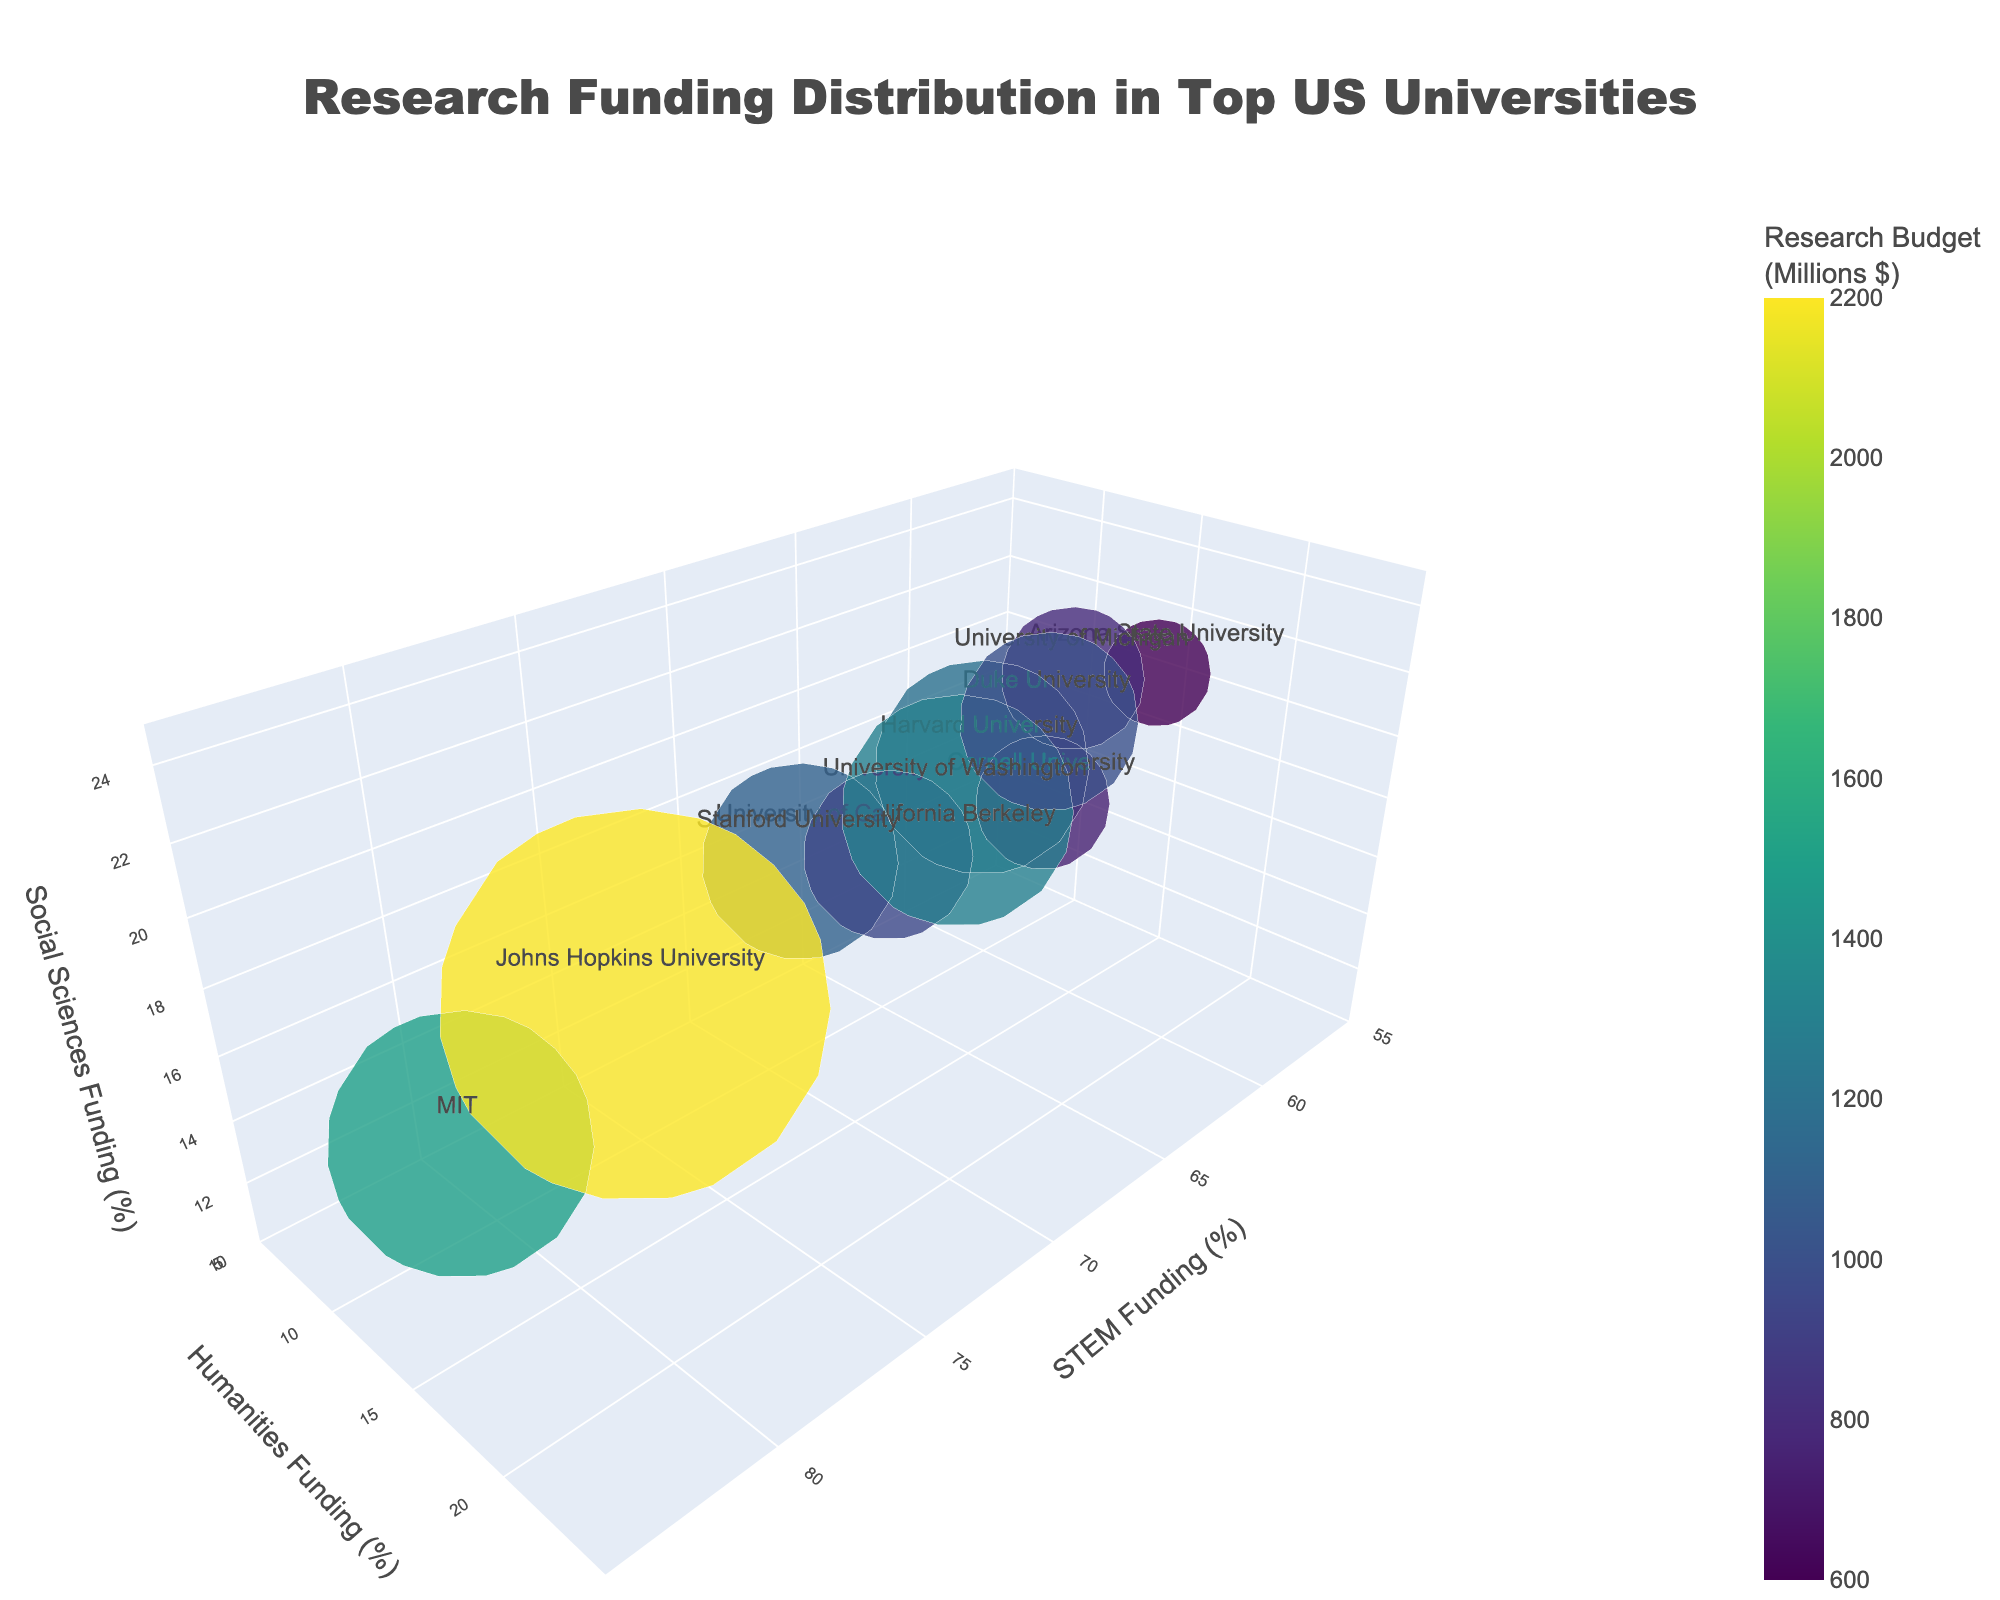How many universities are represented in the chart? Count the number of unique institutions listed in the hovertext information.
Answer: 10 What is the title of the chart? Look at the title at the top center of the chart.
Answer: "Research Funding Distribution in Top US Universities" Which institution has the highest total research budget? Look at the color scale and hover over the largest bubble.
Answer: Johns Hopkins University Which institution allocates the largest percentage of its research funding to Humanities? Hover over each bubble and examine the percentages.
Answer: Arizona State University What are the axes titles in the chart? Look at the labels on the three axes in the 3D space.
Answer: STEM Funding (%), Humanities Funding (%), Social Sciences Funding (%) How is the size of the bubbles determined? Examine the dataset; it mentions that the size is proportional to the total research budget divided by 10.
Answer: Total Research Budget (scaled) Which two institutions have the most similar distribution of research funding across STEM, Humanities, and Social Sciences? Compare the percentages in the hovertexts.
Answer: University of Michigan and Duke University Describe the research funding distribution for Stanford University. Hover over Stanford University and note the percentages for each category.
Answer: STEM: 70%, Humanities: 12%, Social Sciences: 18% What is the total research budget of Harvard University? Hover over Harvard University's bubble and note the budget mentioned.
Answer: $1200M Which institution has the smallest percentage of their budget allocated to Social Sciences? Hover over each bubble and examine the percentages for Social Sciences.
Answer: MIT 